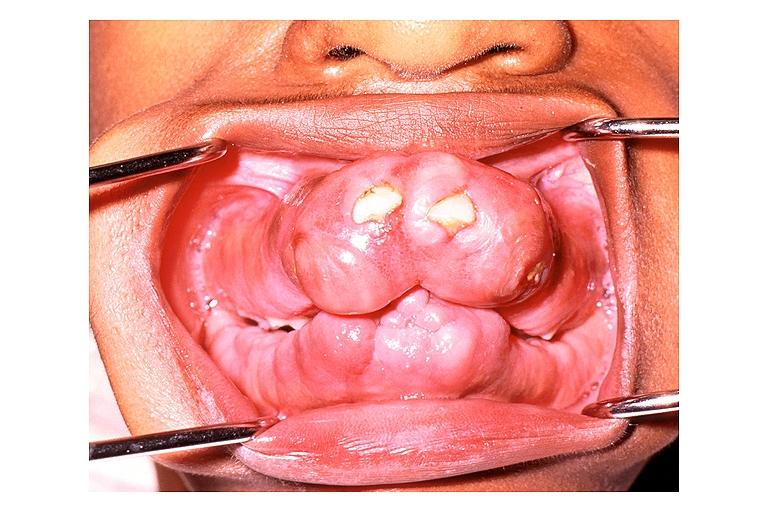s papillary intraductal adenocarcinoma present?
Answer the question using a single word or phrase. No 